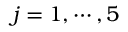Convert formula to latex. <formula><loc_0><loc_0><loc_500><loc_500>j = 1 , \cdots , 5</formula> 